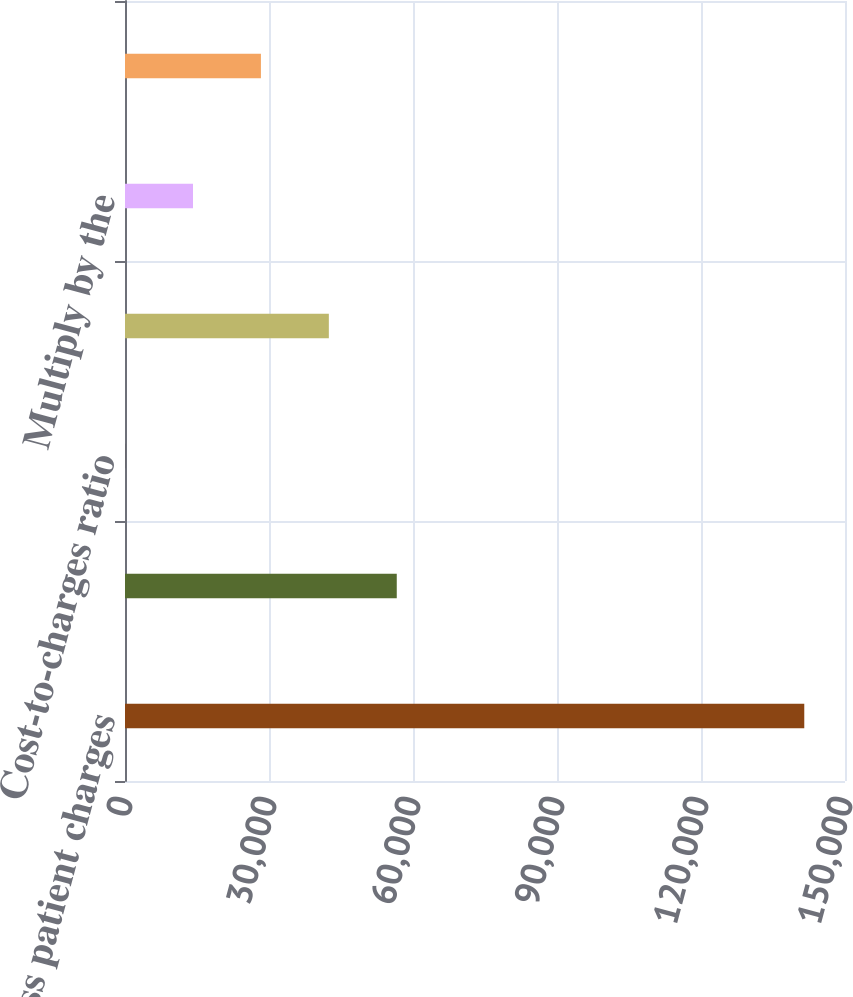Convert chart. <chart><loc_0><loc_0><loc_500><loc_500><bar_chart><fcel>Gross patient charges<fcel>Patient care costs (salaries<fcel>Cost-to-charges ratio<fcel>Total uncompensated care<fcel>Multiply by the<fcel>Estimated cost of total<nl><fcel>141516<fcel>56617.3<fcel>18.1<fcel>42467.5<fcel>14167.9<fcel>28317.7<nl></chart> 